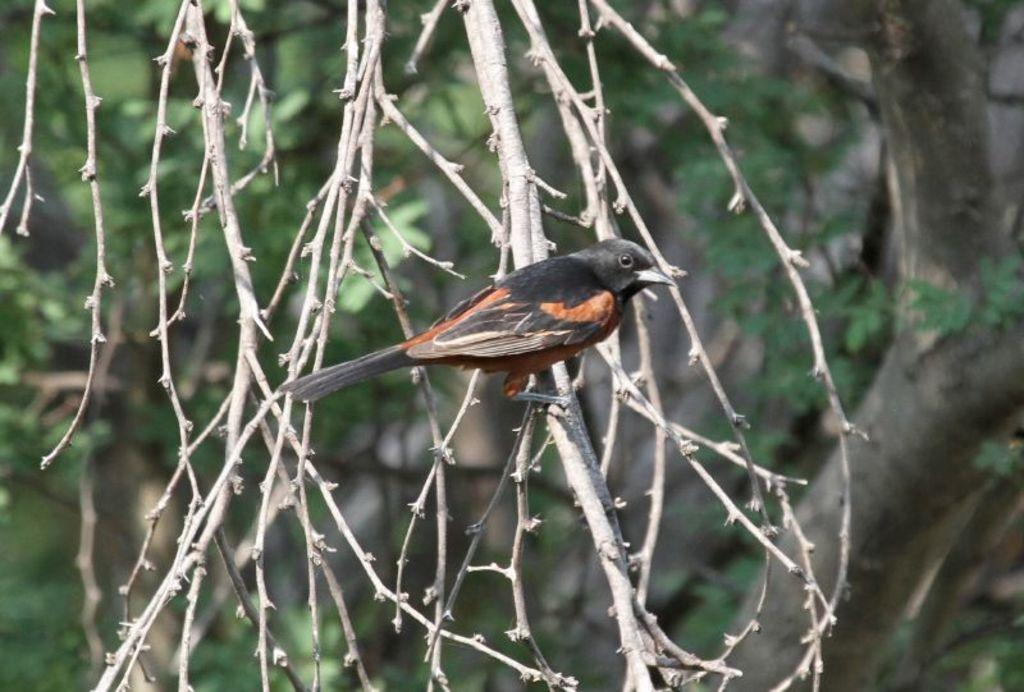What type of animal can be seen in the image? There is a bird in the image. Where is the bird located? The bird is on a tree. What can be seen in the background of the image? There are trees in the background of the image. What type of guitar is the bird playing in the image? There is no guitar present in the image; it features a bird on a tree. Can you see the bird giving a kiss to someone in the image? There is no kiss or interaction with other beings depicted in the image; it shows a bird on a tree. 